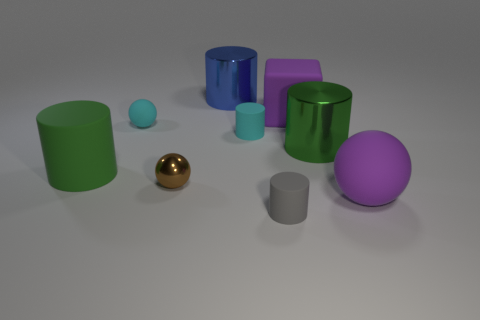Subtract 2 cylinders. How many cylinders are left? 3 Subtract all blue cylinders. How many cylinders are left? 4 Subtract all green matte cylinders. How many cylinders are left? 4 Subtract all red cylinders. Subtract all blue spheres. How many cylinders are left? 5 Add 1 tiny red cubes. How many objects exist? 10 Subtract all blocks. How many objects are left? 8 Subtract all cubes. Subtract all metallic balls. How many objects are left? 7 Add 8 small brown balls. How many small brown balls are left? 9 Add 7 large purple matte cylinders. How many large purple matte cylinders exist? 7 Subtract 0 blue cubes. How many objects are left? 9 